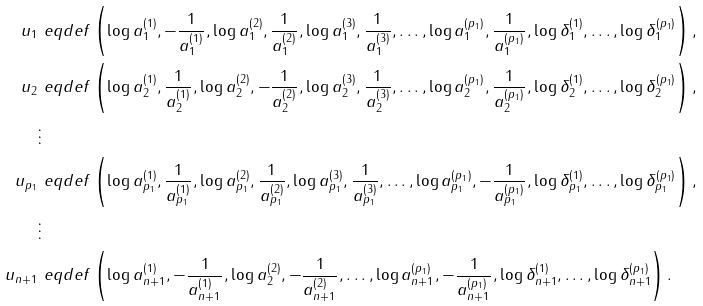Convert formula to latex. <formula><loc_0><loc_0><loc_500><loc_500>u _ { 1 } & \ e q d e f \left ( \log a _ { 1 } ^ { ( 1 ) } , - \frac { 1 } { a _ { 1 } ^ { ( 1 ) } } , \log a _ { 1 } ^ { ( 2 ) } , \frac { 1 } { a _ { 1 } ^ { ( 2 ) } } , \log a _ { 1 } ^ { ( 3 ) } , \frac { 1 } { a _ { 1 } ^ { ( 3 ) } } , \dots , \log a _ { 1 } ^ { ( p _ { 1 } ) } , \frac { 1 } { a _ { 1 } ^ { ( p _ { 1 } ) } } , \log \delta _ { 1 } ^ { ( 1 ) } , \dots , \log \delta _ { 1 } ^ { ( p _ { 1 } ) } \right ) , \\ u _ { 2 } & \ e q d e f \left ( \log a _ { 2 } ^ { ( 1 ) } , \frac { 1 } { a _ { 2 } ^ { ( 1 ) } } , \log a _ { 2 } ^ { ( 2 ) } , - \frac { 1 } { a _ { 2 } ^ { ( 2 ) } } , \log a _ { 2 } ^ { ( 3 ) } , \frac { 1 } { a _ { 2 } ^ { ( 3 ) } } , \dots , \log a _ { 2 } ^ { ( p _ { 1 } ) } , \frac { 1 } { a _ { 2 } ^ { ( p _ { 1 } ) } } , \log \delta _ { 2 } ^ { ( 1 ) } , \dots , \log \delta _ { 2 } ^ { ( p _ { 1 } ) } \right ) , \\ & \vdots \\ u _ { p _ { 1 } } & \ e q d e f \left ( \log a _ { p _ { 1 } } ^ { ( 1 ) } , \frac { 1 } { a _ { p _ { 1 } } ^ { ( 1 ) } } , \log a _ { p _ { 1 } } ^ { ( 2 ) } , \frac { 1 } { a _ { p _ { 1 } } ^ { ( 2 ) } } , \log a _ { p _ { 1 } } ^ { ( 3 ) } , \frac { 1 } { a _ { p _ { 1 } } ^ { ( 3 ) } } , \dots , \log a _ { p _ { 1 } } ^ { ( p _ { 1 } ) } , - \frac { 1 } { a _ { p _ { 1 } } ^ { ( p _ { 1 } ) } } , \log \delta _ { p _ { 1 } } ^ { ( 1 ) } , \dots , \log \delta _ { p _ { 1 } } ^ { ( p _ { 1 } ) } \right ) , \\ & \vdots \\ u _ { n + 1 } & \ e q d e f \left ( \log a _ { n + 1 } ^ { ( 1 ) } , - \frac { 1 } { a _ { n + 1 } ^ { ( 1 ) } } , \log a _ { 2 } ^ { ( 2 ) } , - \frac { 1 } { a _ { n + 1 } ^ { ( 2 ) } } , \dots , \log a _ { n + 1 } ^ { ( p _ { 1 } ) } , - \frac { 1 } { a _ { n + 1 } ^ { ( p _ { 1 } ) } } , \log \delta _ { n + 1 } ^ { ( 1 ) } , \dots , \log \delta _ { n + 1 } ^ { ( p _ { 1 } ) } \right ) . \\</formula> 